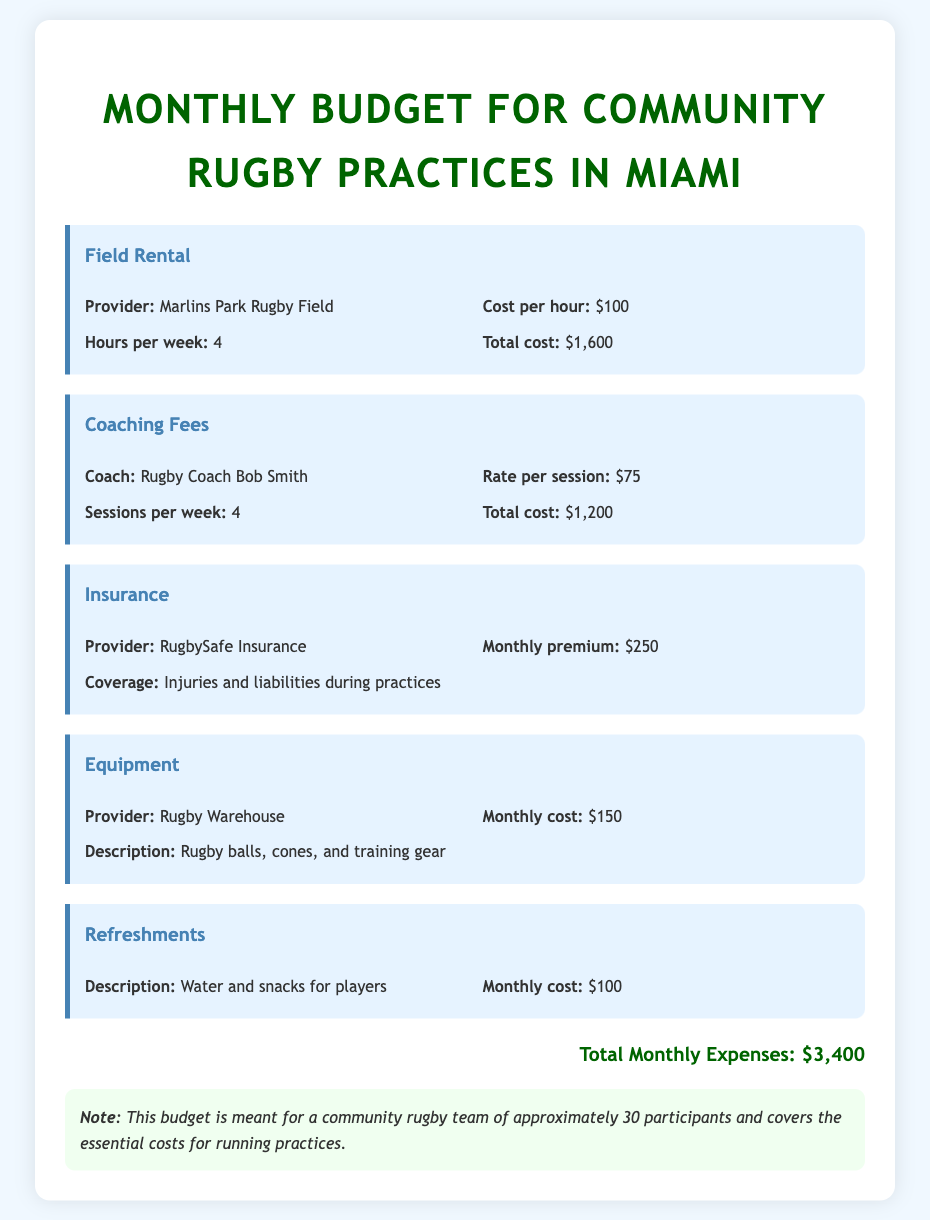What is the total cost for field rental? The total cost for field rental is listed as $1,600 in the document.
Answer: $1,600 What is the rate per session for the coach? The document states that the rate per session for Rugby Coach Bob Smith is $75.
Answer: $75 How many hours per week is the field rented? The budget specifies that the field is rented for 4 hours per week.
Answer: 4 What is the monthly premium for insurance? The document indicates that the monthly premium for RugbySafe Insurance is $250.
Answer: $250 What is the total monthly expense for organizing rugby practices? The total monthly expenses, as stated in the document, is $3,400.
Answer: $3,400 How many participants does this budget cover? The note mentions that the budget is for approximately 30 participants.
Answer: 30 What is included in the equipment cost? The document describes the equipment cost as covering rugby balls, cones, and training gear.
Answer: Rugby balls, cones, and training gear How much is allocated for refreshments? The budget allocates $100 for refreshments, specified in the document.
Answer: $100 What coverage does the insurance provide? The document states that the insurance covers injuries and liabilities during practices.
Answer: Injuries and liabilities during practices 